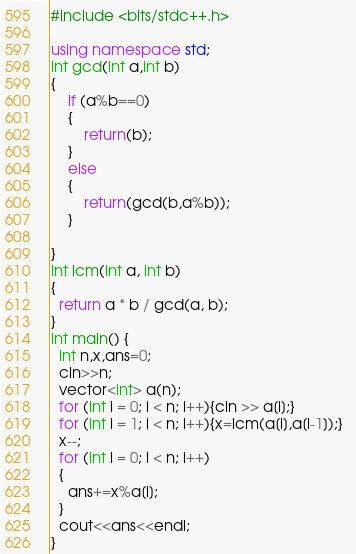Convert code to text. <code><loc_0><loc_0><loc_500><loc_500><_C++_>#include <bits/stdc++.h>

using namespace std;
int gcd(int a,int b)
{
	if (a%b==0)
	{
		return(b);
    }
	else
	{
		return(gcd(b,a%b));
    }

}
int lcm(int a, int b)
{
  return a * b / gcd(a, b);
}
int main() {
  int n,x,ans=0;
  cin>>n;
  vector<int> a(n);
  for (int i = 0; i < n; i++){cin >> a[i];}
  for (int i = 1; i < n; i++){x=lcm(a[i],a[i-1]);}  
  x--;
  for (int i = 0; i < n; i++)
  {
    ans+=x%a[i];
  }
  cout<<ans<<endl;
}</code> 